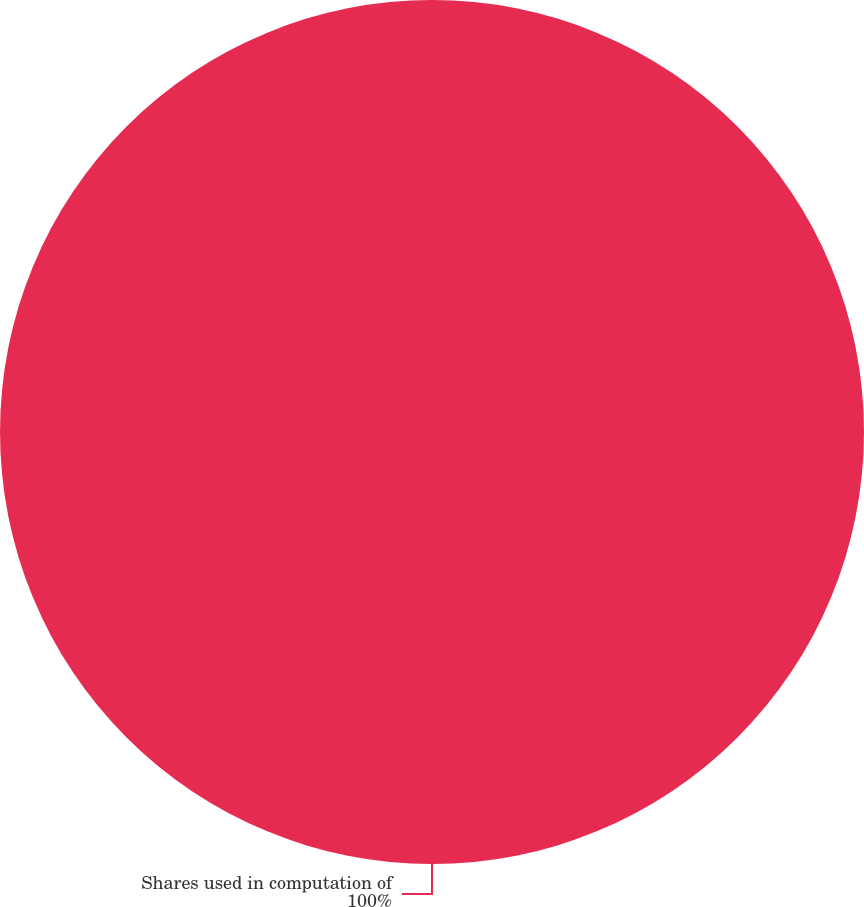Convert chart. <chart><loc_0><loc_0><loc_500><loc_500><pie_chart><fcel>Shares used in computation of<nl><fcel>100.0%<nl></chart> 